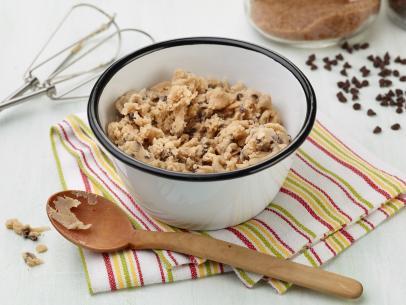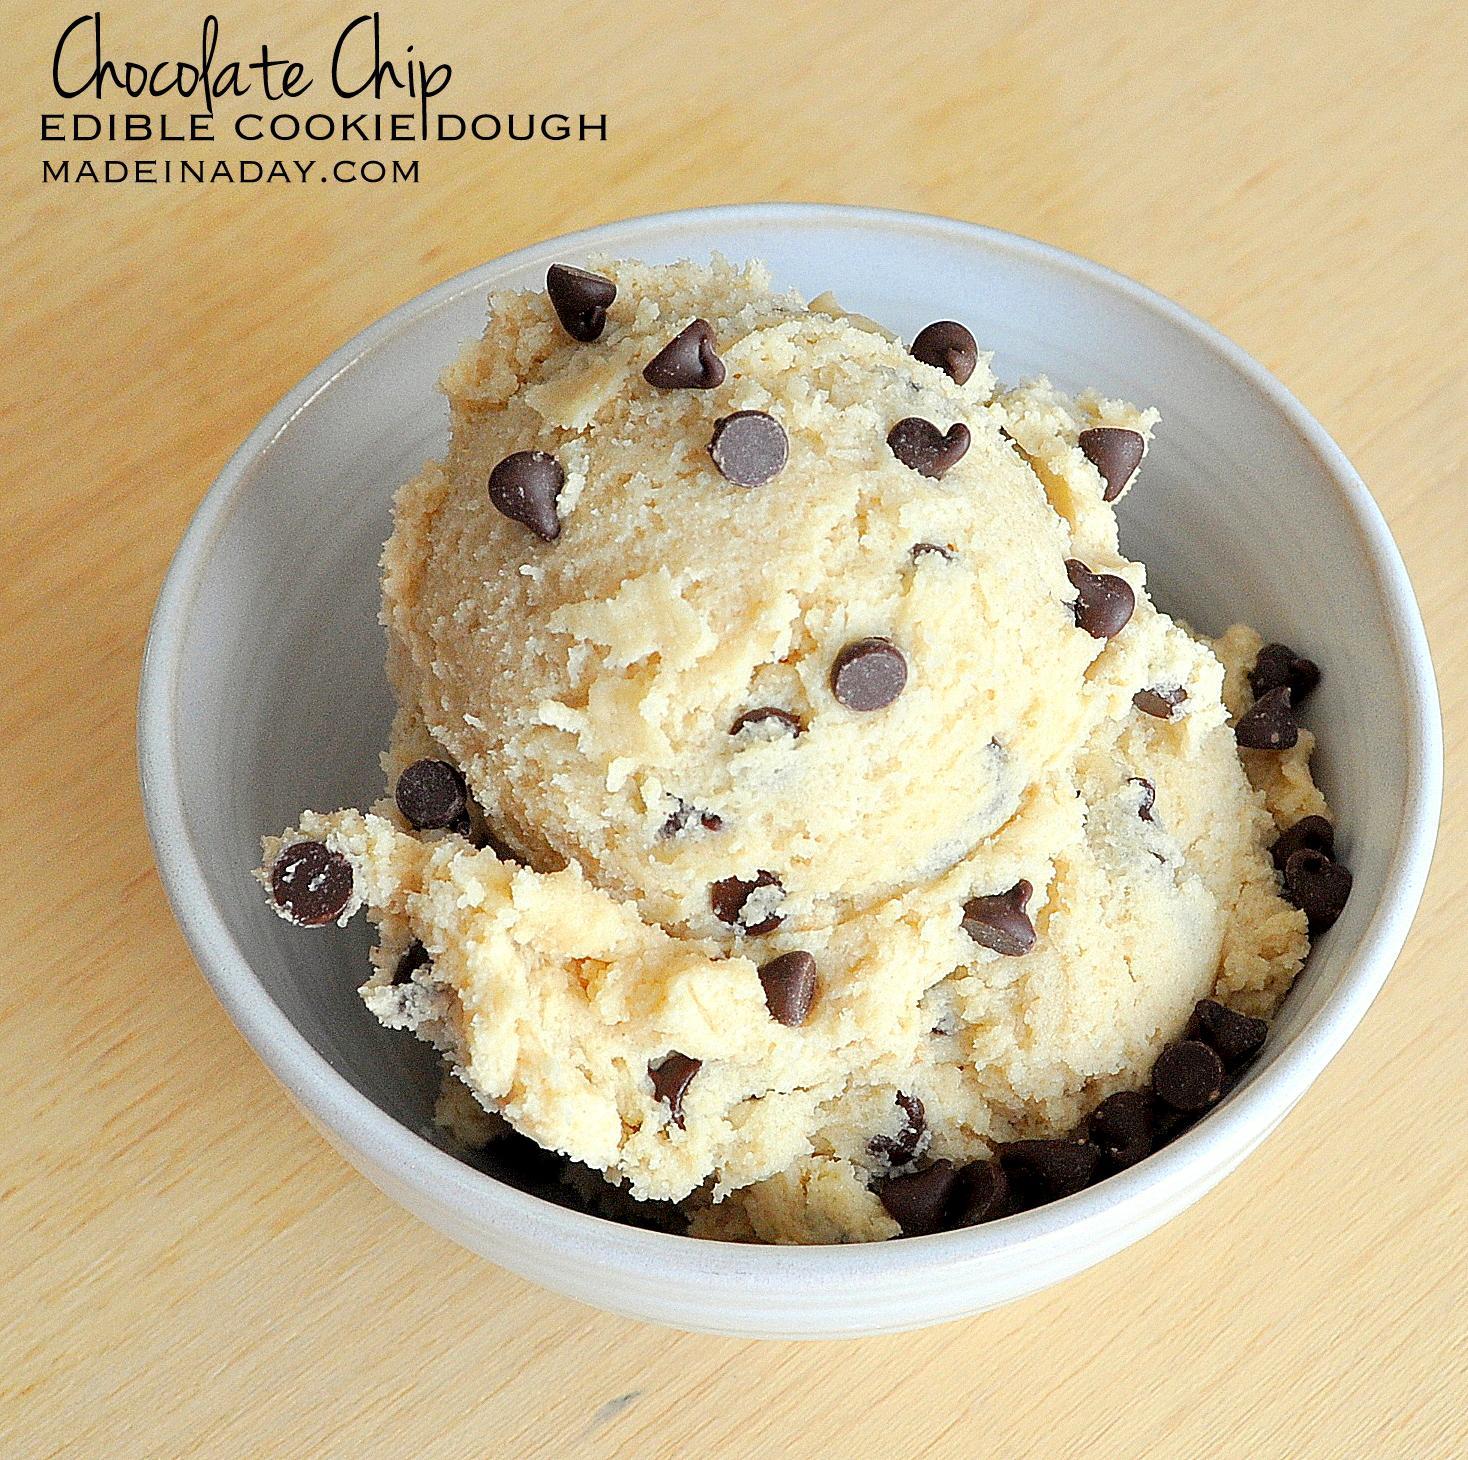The first image is the image on the left, the second image is the image on the right. Evaluate the accuracy of this statement regarding the images: "Someone is using a wooden spoon to make chocolate chip cookies in one of the pictures.". Is it true? Answer yes or no. Yes. 